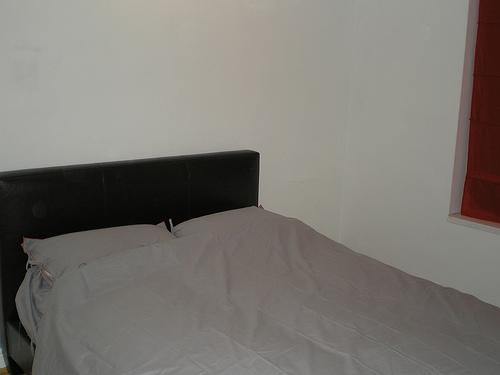Provide a brief description of the main focus of the image. The image features a bed with a dark rectangular headboard, white linen sheet, two white pillows, and grey bed sheets in the center of a room with white walls and a window with a red shade. How many instances of the white fabric on cover are present in the image? There are two instances of the white fabric on cover in the image. Mention one distinct feature of the headboard and describe the material it is made of. The headboard features a simple, smooth design and is made of black leather. Describe the color and material of the bed. The bed is brown in color and is made of wood, with a black leather headboard. How many pillows are visible on the bed, and what colors are they? There are two white pillows visible on the bed. 